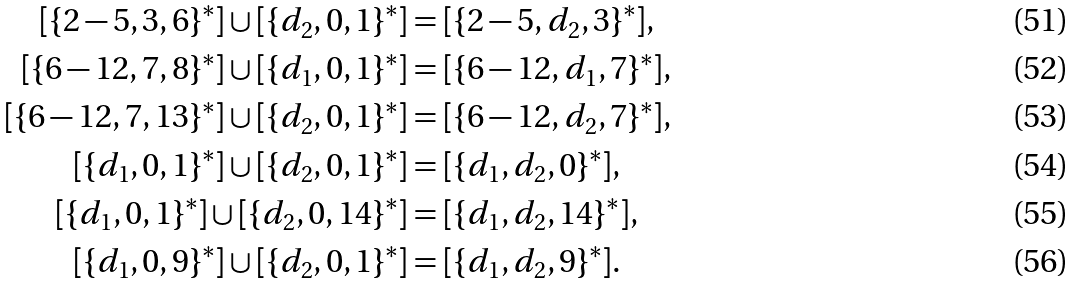Convert formula to latex. <formula><loc_0><loc_0><loc_500><loc_500>[ \{ 2 - 5 , 3 , 6 \} ^ { * } ] \cup [ \{ d _ { 2 } , 0 , 1 \} ^ { * } ] & = [ \{ 2 - 5 , d _ { 2 } , 3 \} ^ { * } ] , \\ [ \{ 6 - 1 2 , 7 , 8 \} ^ { * } ] \cup [ \{ d _ { 1 } , 0 , 1 \} ^ { * } ] & = [ \{ 6 - 1 2 , d _ { 1 } , 7 \} ^ { * } ] , \\ [ \{ 6 - 1 2 , 7 , 1 3 \} ^ { * } ] \cup [ \{ d _ { 2 } , 0 , 1 \} ^ { * } ] & = [ \{ 6 - 1 2 , d _ { 2 } , 7 \} ^ { * } ] , \\ [ \{ d _ { 1 } , 0 , 1 \} ^ { * } ] \cup [ \{ d _ { 2 } , 0 , 1 \} ^ { * } ] & = [ \{ d _ { 1 } , d _ { 2 } , 0 \} ^ { * } ] , \\ [ \{ d _ { 1 } , 0 , 1 \} ^ { * } ] \cup [ \{ d _ { 2 } , 0 , 1 4 \} ^ { * } ] & = [ \{ d _ { 1 } , d _ { 2 } , 1 4 \} ^ { * } ] , \\ [ \{ d _ { 1 } , 0 , 9 \} ^ { * } ] \cup [ \{ d _ { 2 } , 0 , 1 \} ^ { * } ] & = [ \{ d _ { 1 } , d _ { 2 } , 9 \} ^ { * } ] .</formula> 